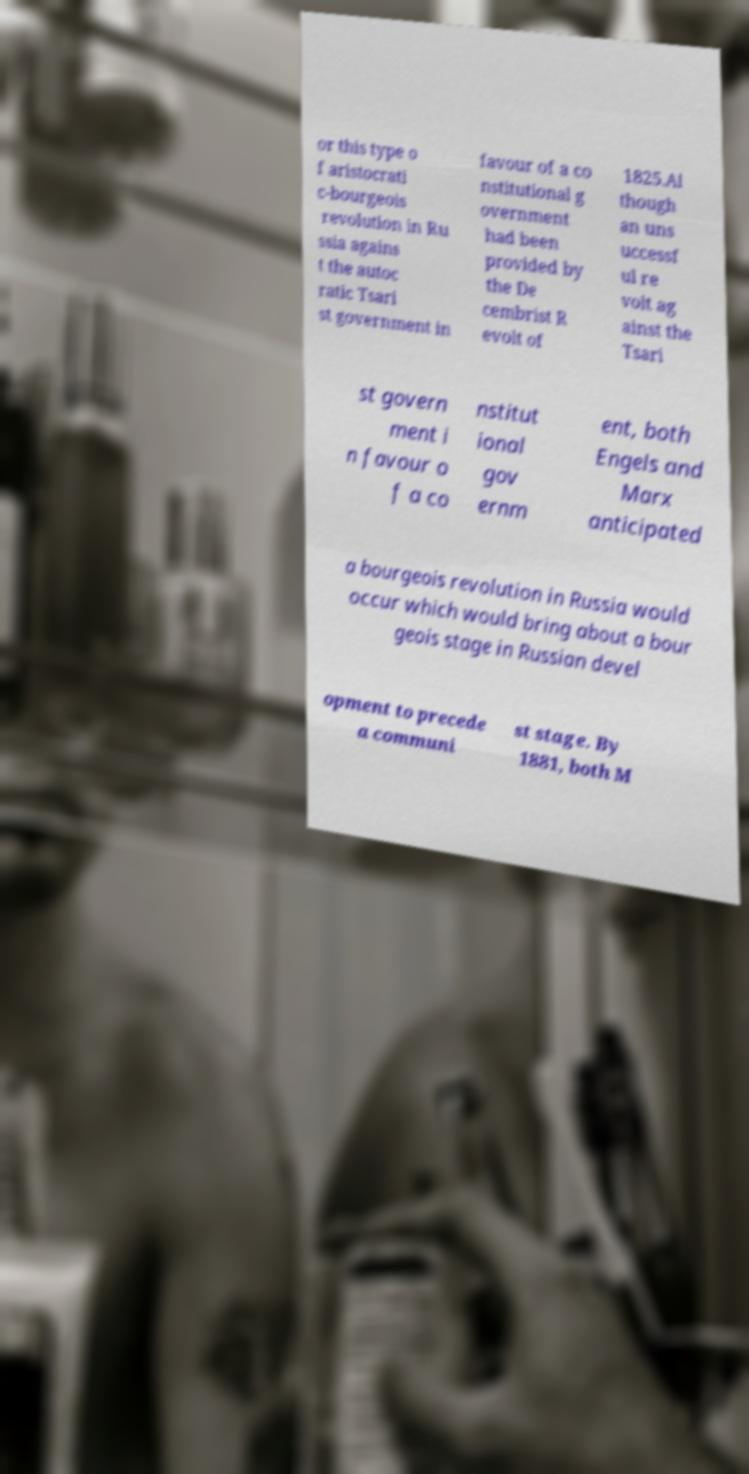What messages or text are displayed in this image? I need them in a readable, typed format. or this type o f aristocrati c-bourgeois revolution in Ru ssia agains t the autoc ratic Tsari st government in favour of a co nstitutional g overnment had been provided by the De cembrist R evolt of 1825.Al though an uns uccessf ul re volt ag ainst the Tsari st govern ment i n favour o f a co nstitut ional gov ernm ent, both Engels and Marx anticipated a bourgeois revolution in Russia would occur which would bring about a bour geois stage in Russian devel opment to precede a communi st stage. By 1881, both M 